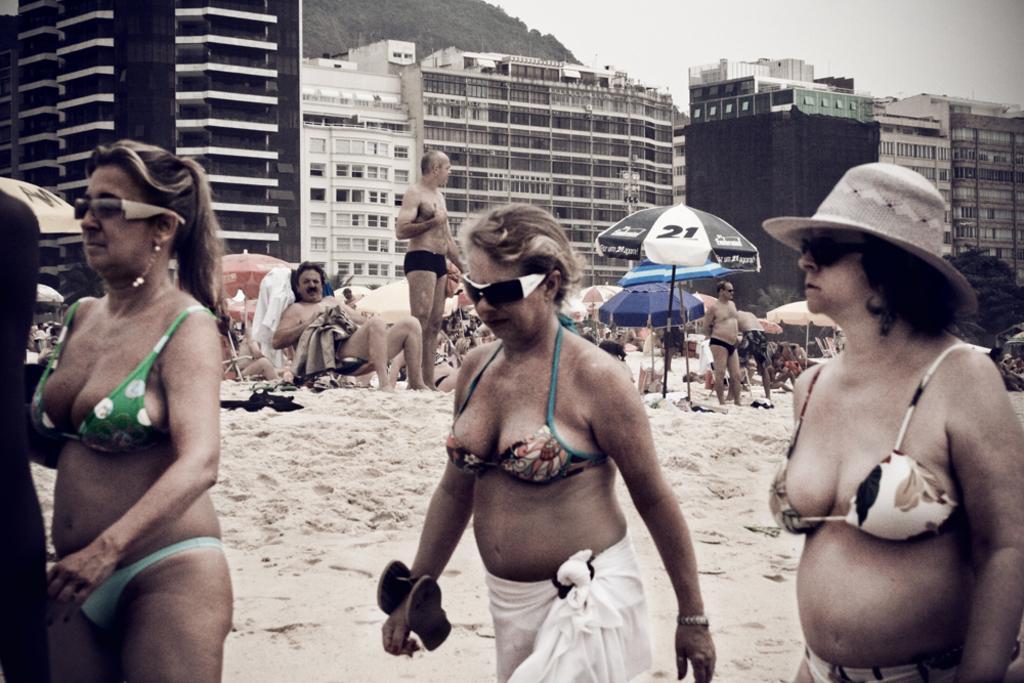Could you give a brief overview of what you see in this image? Front we can see three people. Background there are umbrellas, people and buildings. 